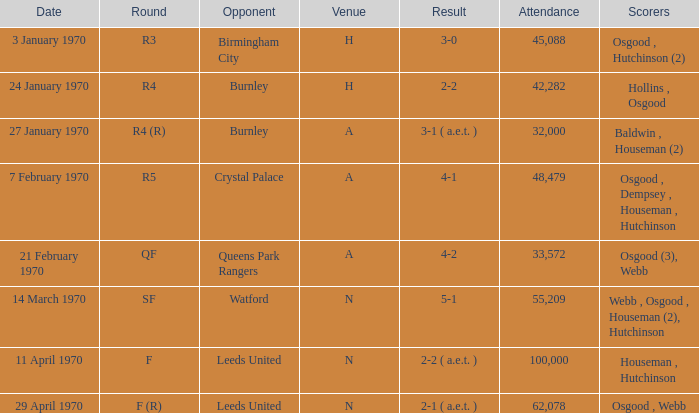In which round did the game at n venue have a score of 5-1? SF. 